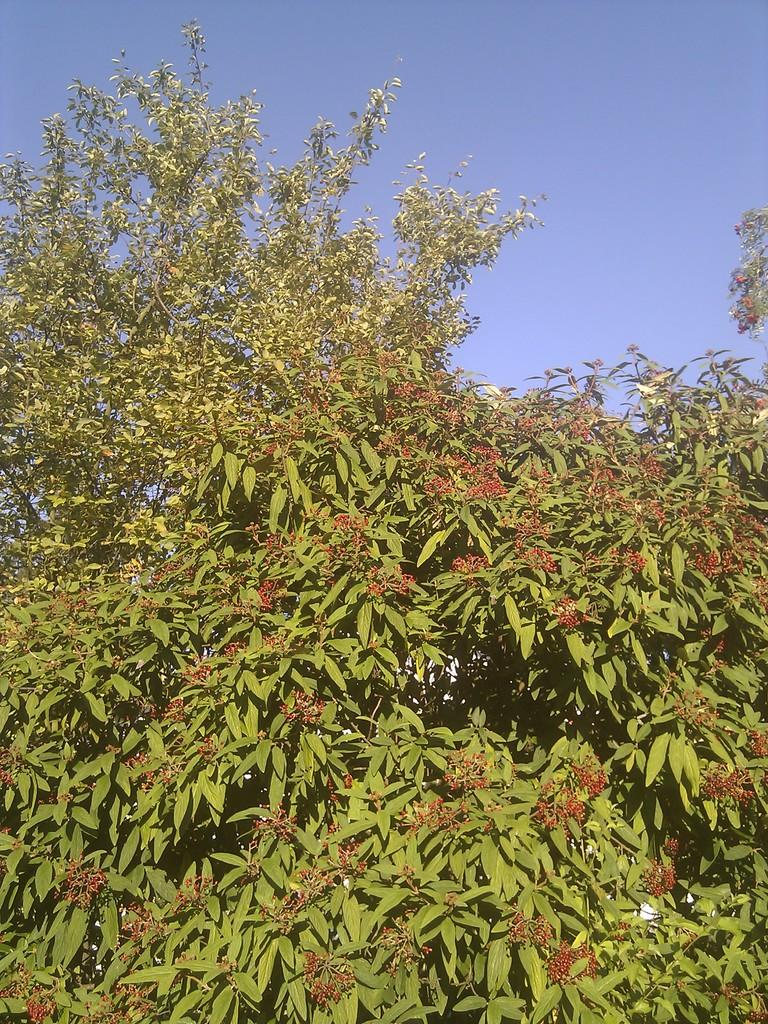What type of vegetation can be seen in the image? There are trees in the image. What is visible at the top of the image? The sky is visible at the top of the image. What color is the crayon being used to draw the trees in the image? There is no crayon present in the image; it features trees and the sky. How many brothers are visible in the image? There are no people, including brothers, present in the image. 